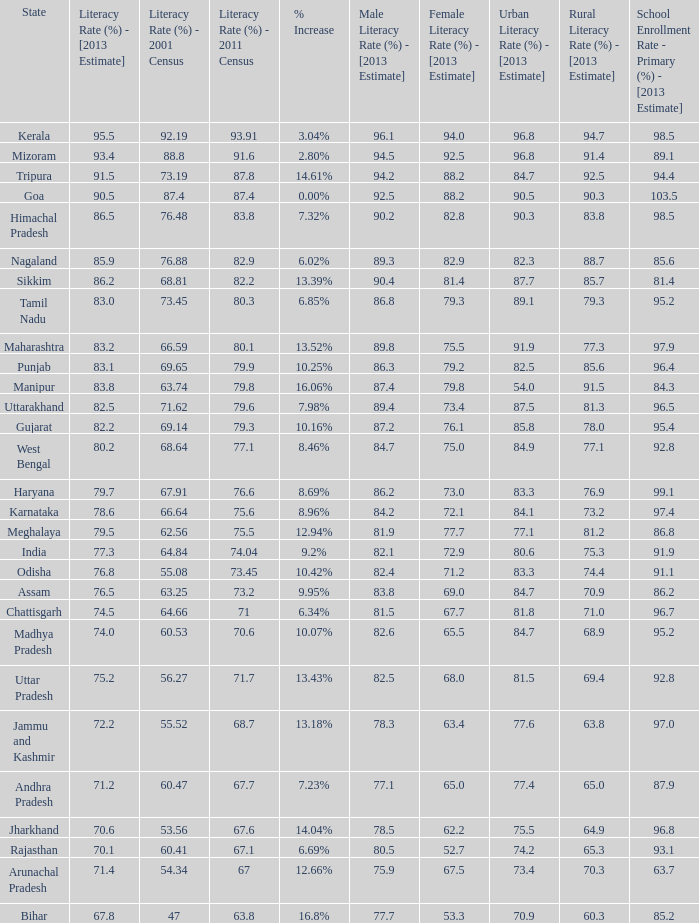What was the literacy rate published in the 2001 census for the state that saw a 12.66% increase? 54.34. 